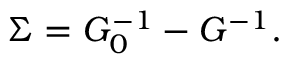<formula> <loc_0><loc_0><loc_500><loc_500>\Sigma = G _ { 0 } ^ { - 1 } - G ^ { - 1 } .</formula> 